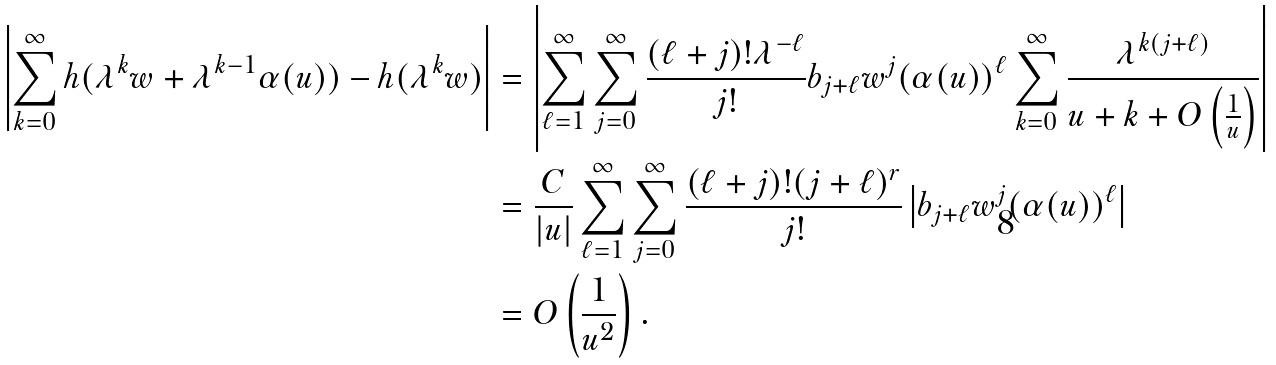<formula> <loc_0><loc_0><loc_500><loc_500>\left | \sum _ { k = 0 } ^ { \infty } h ( \lambda ^ { k } w + \lambda ^ { k - 1 } \alpha ( u ) ) - h ( \lambda ^ { k } w ) \right | & = \left | \sum _ { \ell = 1 } ^ { \infty } \sum _ { j = 0 } ^ { \infty } \frac { ( \ell + j ) ! \lambda ^ { - \ell } } { j ! } b _ { j + \ell } w ^ { j } ( \alpha ( u ) ) ^ { \ell } \sum _ { k = 0 } ^ { \infty } \frac { \lambda ^ { k ( j + \ell ) } } { u + k + O \left ( \frac { 1 } { u } \right ) } \right | \\ & = \frac { C } { | u | } \sum _ { \ell = 1 } ^ { \infty } \sum _ { j = 0 } ^ { \infty } \frac { ( \ell + j ) ! ( j + \ell ) ^ { r } } { j ! } \left | b _ { j + \ell } w ^ { j } ( \alpha ( u ) ) ^ { \ell } \right | \\ & = O \left ( \frac { 1 } { u ^ { 2 } } \right ) .</formula> 